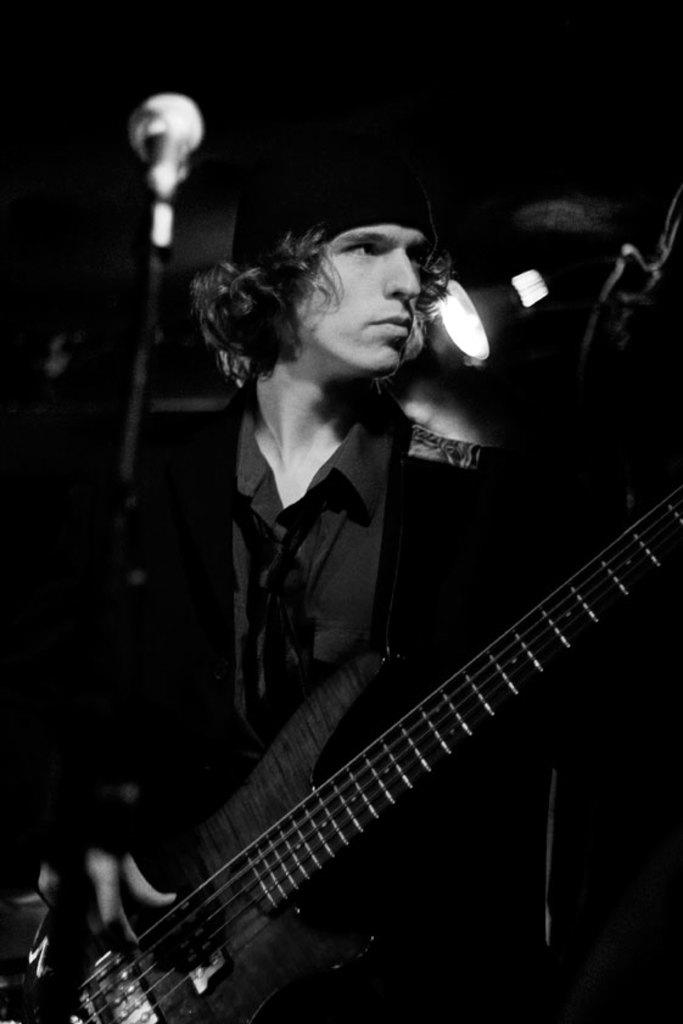What is the main subject of the image? There is a person in the image. What is the person holding in the image? The person is holding a guitar. What color jacket is the person wearing? The person is wearing a black color jacket. What can be seen in the background of the image? There is a light in the background of the image. What type of flock can be seen flying in the image? There is no flock of birds or animals visible in the image; it features a person holding a guitar. What kind of quilt is being used as a prop in the image? There is no quilt present in the image. 